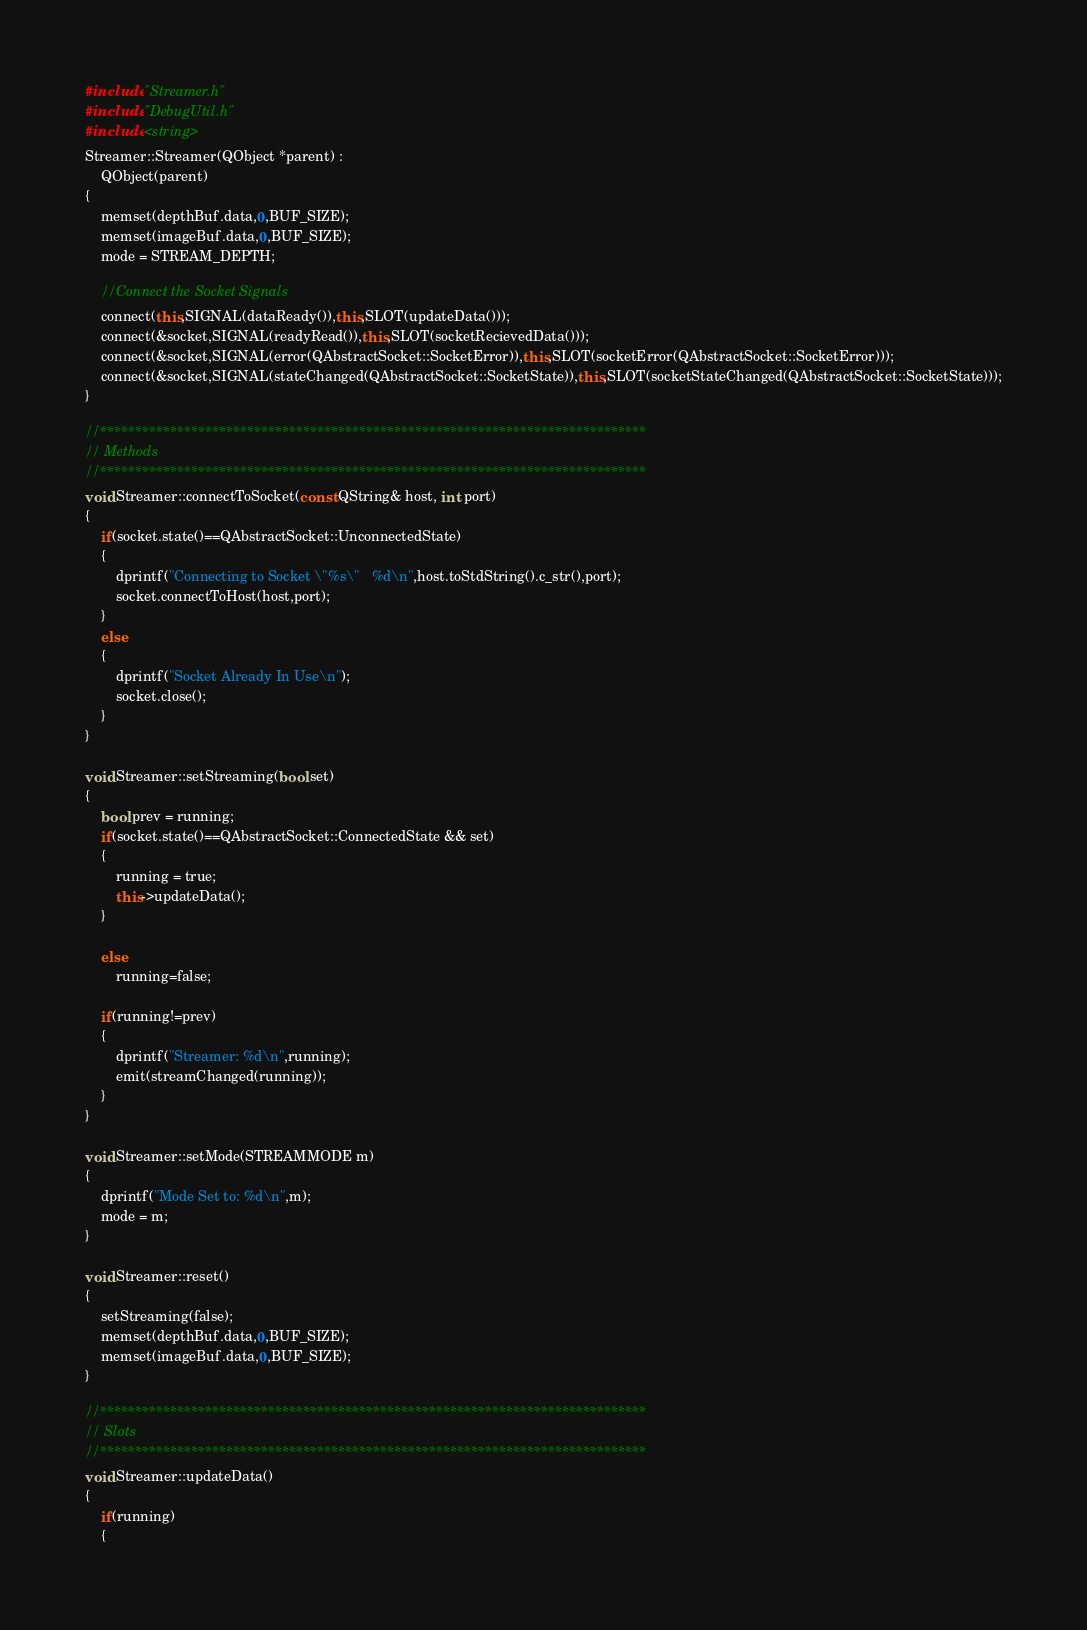<code> <loc_0><loc_0><loc_500><loc_500><_C++_>#include "Streamer.h"
#include "DebugUtil.h"
#include <string>
Streamer::Streamer(QObject *parent) :
    QObject(parent)
{
    memset(depthBuf.data,0,BUF_SIZE);
    memset(imageBuf.data,0,BUF_SIZE);
    mode = STREAM_DEPTH;

    //Connect the Socket Signals
    connect(this,SIGNAL(dataReady()),this,SLOT(updateData()));
    connect(&socket,SIGNAL(readyRead()),this,SLOT(socketRecievedData()));
    connect(&socket,SIGNAL(error(QAbstractSocket::SocketError)),this,SLOT(socketError(QAbstractSocket::SocketError)));
    connect(&socket,SIGNAL(stateChanged(QAbstractSocket::SocketState)),this,SLOT(socketStateChanged(QAbstractSocket::SocketState)));
}

//******************************************************************************
// Methods
//******************************************************************************
void Streamer::connectToSocket(const QString& host, int port)
{
    if(socket.state()==QAbstractSocket::UnconnectedState)
    {
        dprintf("Connecting to Socket \"%s\"   %d\n",host.toStdString().c_str(),port);
        socket.connectToHost(host,port);
    }
    else
    {
        dprintf("Socket Already In Use\n");
        socket.close();
    }
}

void Streamer::setStreaming(bool set)
{
    bool prev = running;
    if(socket.state()==QAbstractSocket::ConnectedState && set)
    {
        running = true;
        this->updateData();
    }

    else
        running=false;

    if(running!=prev)
    {
        dprintf("Streamer: %d\n",running);
        emit(streamChanged(running));
    }
}

void Streamer::setMode(STREAMMODE m)
{
    dprintf("Mode Set to: %d\n",m);
    mode = m;
}

void Streamer::reset()
{
    setStreaming(false);
    memset(depthBuf.data,0,BUF_SIZE);
    memset(imageBuf.data,0,BUF_SIZE);
}

//******************************************************************************
// Slots
//******************************************************************************
void Streamer::updateData()
{
    if(running)
    {</code> 